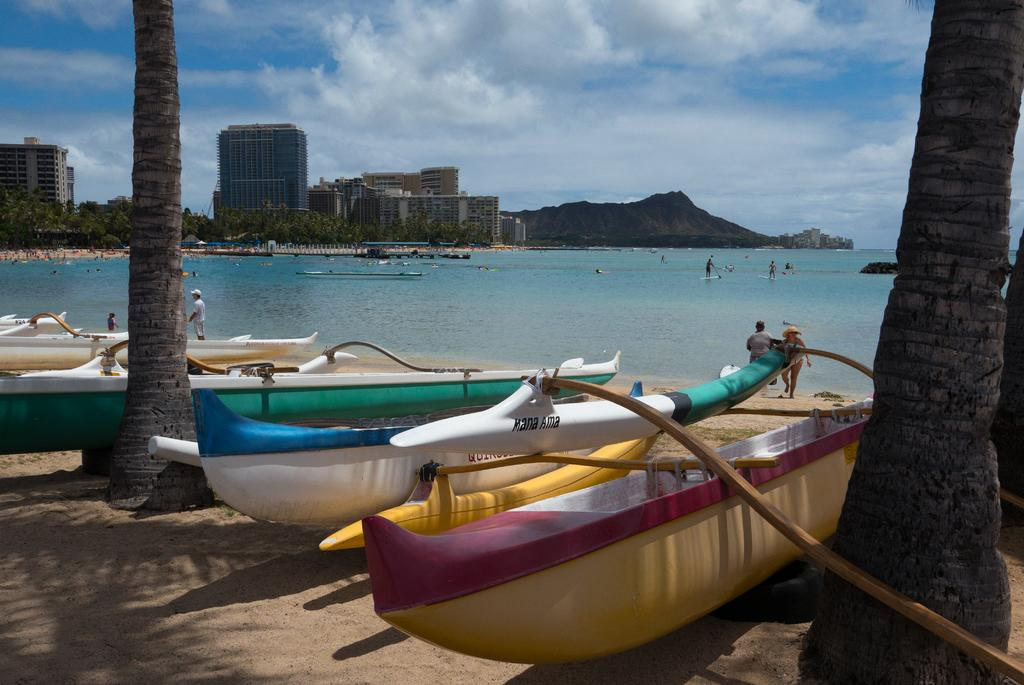What type of boats are in the image? There are skiffs in the image. Where are the skiffs located in relation to the trees? The skiffs are placed between trees. What can be seen in the background of the image? There is an ocean, people, buildings, and trees in the background of the image. How is the sky depicted in the image? The sky is clear in the image. What type of prose can be heard being read aloud in the image? There is no indication in the image that any prose is being read aloud, so it cannot be determined from the picture. 